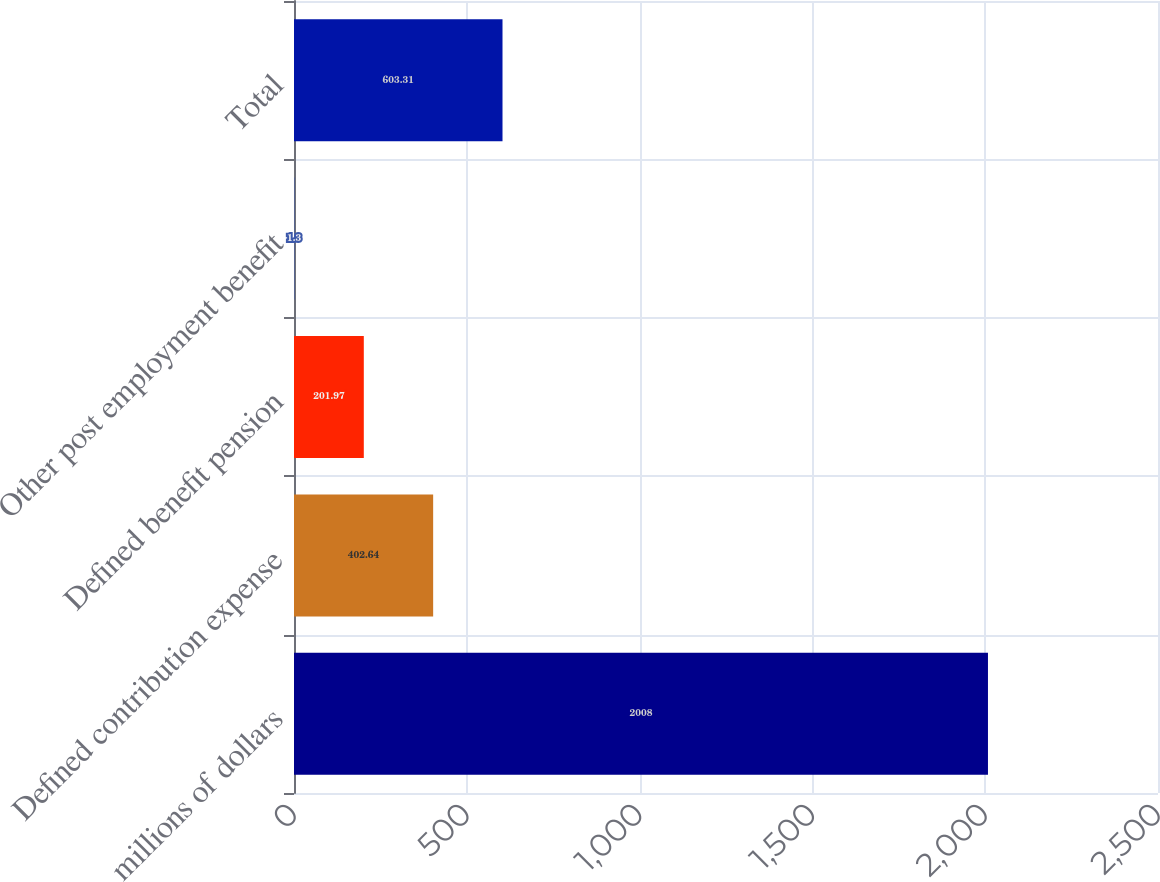Convert chart to OTSL. <chart><loc_0><loc_0><loc_500><loc_500><bar_chart><fcel>millions of dollars<fcel>Defined contribution expense<fcel>Defined benefit pension<fcel>Other post employment benefit<fcel>Total<nl><fcel>2008<fcel>402.64<fcel>201.97<fcel>1.3<fcel>603.31<nl></chart> 